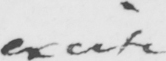Transcribe the text shown in this historical manuscript line. excite 